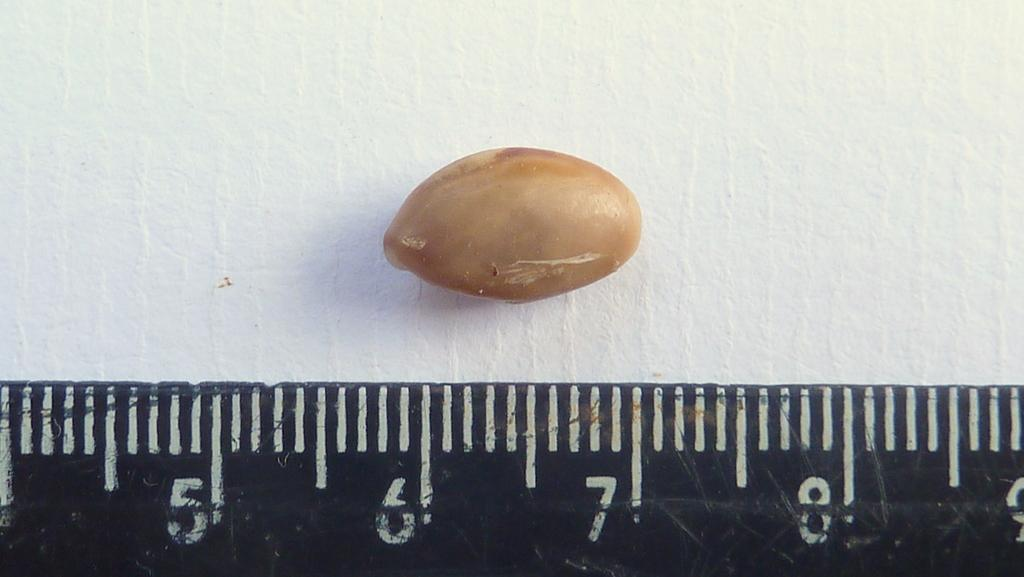<image>
Write a terse but informative summary of the picture. A brown object lays near the 6 and 7 centimeter mark of a ruler. 